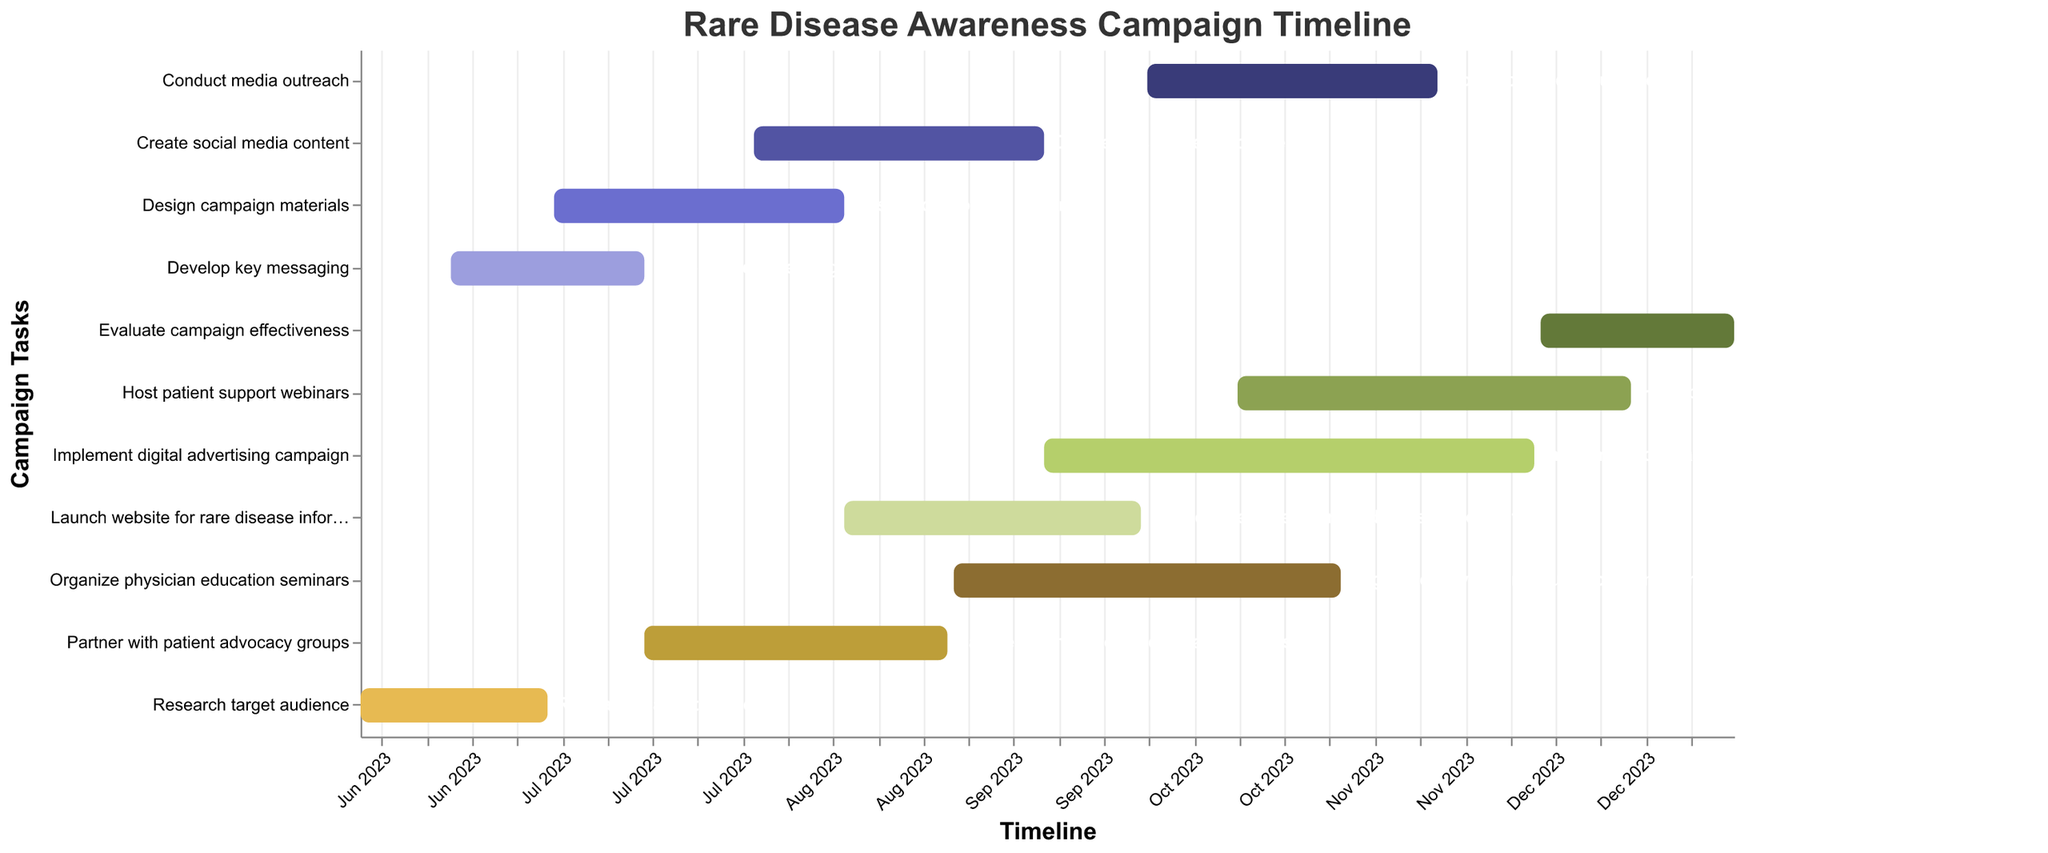What is the title of the Gantt Chart? The title of the chart is typically placed at the top of the figure and serves as a summary of the chart's purpose. In this case, it describes the overall theme.
Answer: Rare Disease Awareness Campaign Timeline How long does the "Research target audience" task last? The duration of the "Research target audience" task can be calculated by finding the difference between the end date (2023-06-30) and the start date (2023-06-01).
Answer: 30 days Which task overlaps with the "Design campaign materials" task? By inspecting the task timelines, "Partner with patient advocacy groups" overlaps with "Design campaign materials" since it starts on 2023-07-15 and ends on 2023-08-31.
Answer: Partner with patient advocacy groups How many tasks are running concurrently in September 2023? By checking the timelines of tasks across September 2023, we find five tasks are active: "Create social media content," "Launch website for rare disease information," "Organize physician education seminars," "Implement digital advertising campaign," and "Conduct media outreach."
Answer: 5 tasks Which task finishes first in August 2023? Among the tasks in August 2023, "Design campaign materials" ends on 2023-08-15, which is earlier than the other tasks ending in August.
Answer: Design campaign materials What is the longest task in the campaign timeline and its duration? The task with the broadest span is "Host patient support webinars," running from 2023-10-15 to 2023-12-15. Duration calculation: December 15, 2023 - October 15, 2023 = 62 days.
Answer: Host patient support webinars, 62 days Is there any overlap between "Create social media content" and "Launch website for rare disease information"? "Create social media content" runs from 2023-08-01 to 2023-09-15, while "Launch website for rare disease information" runs from 2023-08-15 to 2023-09-30. Both tasks overlap from 2023-08-15 to 2023-09-15.
Answer: Yes 